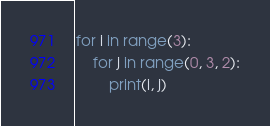<code> <loc_0><loc_0><loc_500><loc_500><_Python_>for i in range(3):
    for j in range(0, 3, 2):
        print(i, j)
</code> 